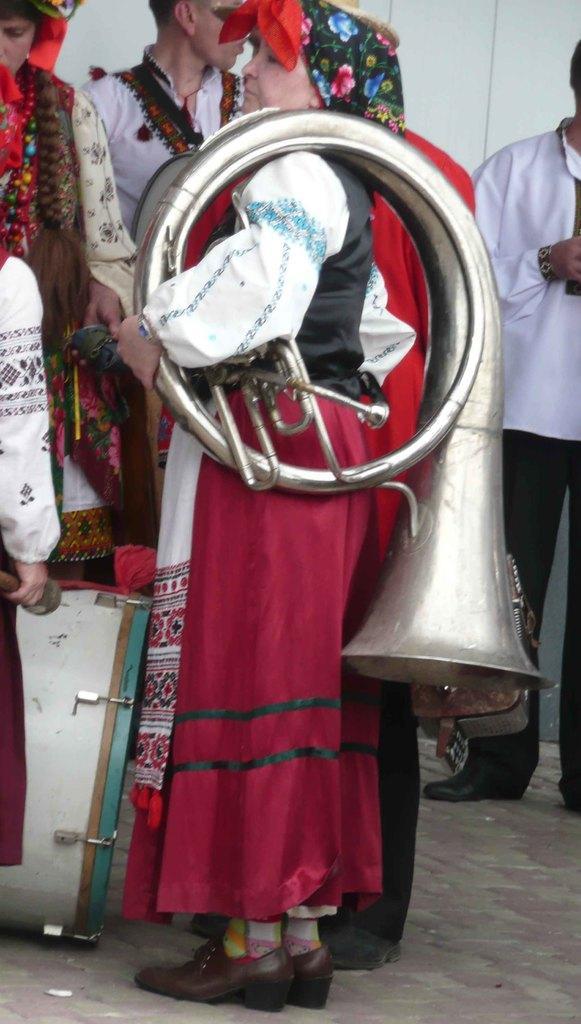Describe this image in one or two sentences. In this image I can see few people standing. They are wearing different dress. One person is holding musical instrument. I can see a drum and a white wall. 